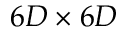<formula> <loc_0><loc_0><loc_500><loc_500>6 D \times 6 D</formula> 